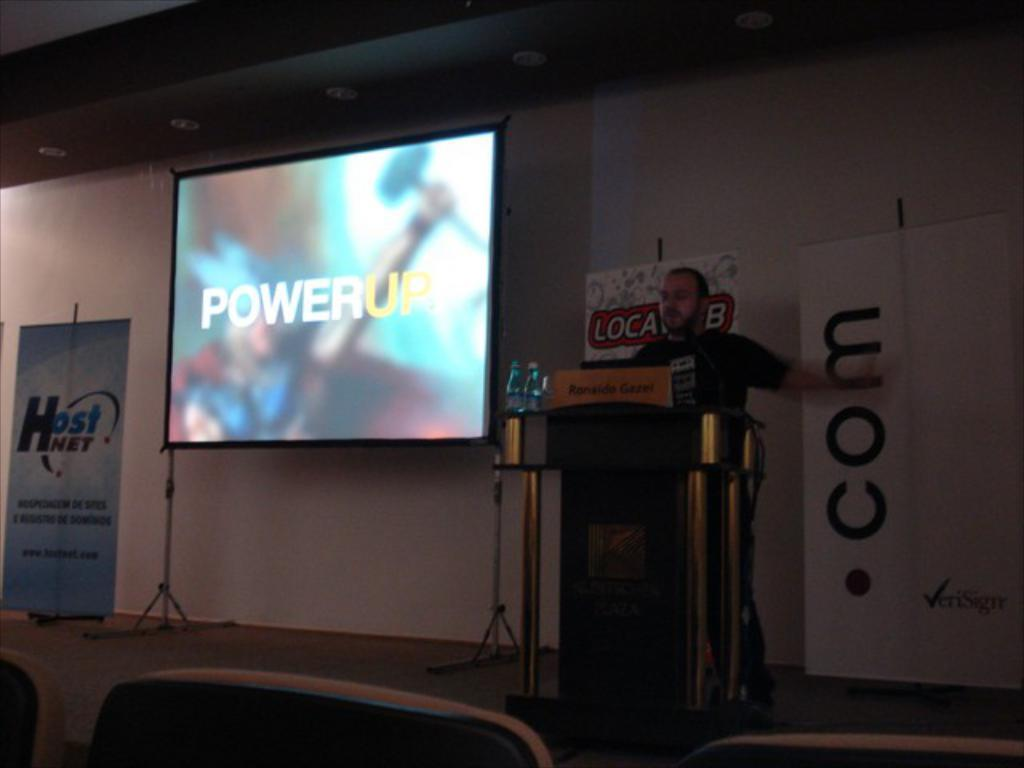Provide a one-sentence caption for the provided image. A man behind a podium stands next to a screen which reads "Power Up". 